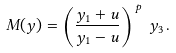Convert formula to latex. <formula><loc_0><loc_0><loc_500><loc_500>M ( y ) = \left ( \frac { y _ { 1 } + u } { y _ { 1 } - u } \right ) ^ { \, p } \, y _ { 3 } \, .</formula> 